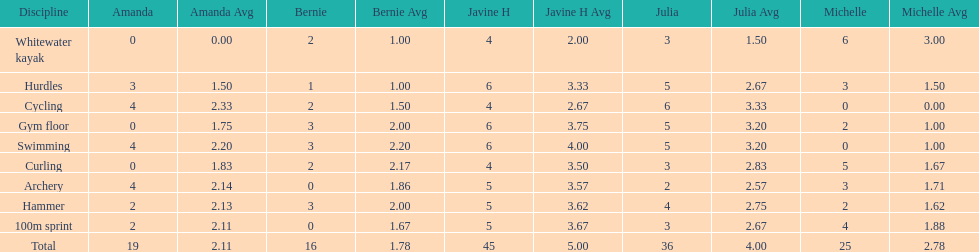Which of the girls had the least amount in archery? Bernie. 